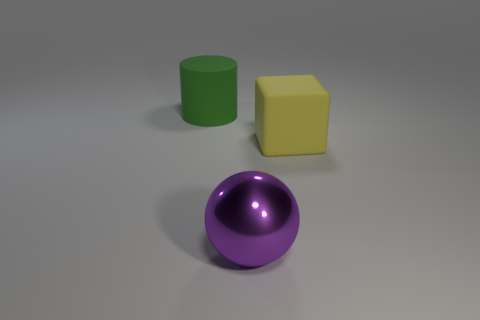Are there any other things that are made of the same material as the big ball?
Offer a terse response. No. How many big things are gray blocks or rubber things?
Your answer should be compact. 2. Is the large object behind the large yellow cube made of the same material as the large yellow cube?
Your answer should be very brief. Yes. There is a large object that is behind the big thing to the right of the big purple metal sphere; what is it made of?
Keep it short and to the point. Rubber. What size is the rubber thing that is in front of the thing that is to the left of the thing that is in front of the yellow matte thing?
Keep it short and to the point. Large. What number of cyan things are either large blocks or balls?
Your answer should be very brief. 0. There is a matte object that is to the right of the purple thing; is its shape the same as the purple object?
Make the answer very short. No. Are there more large rubber things that are behind the big rubber cube than gray objects?
Offer a terse response. Yes. How many yellow cubes have the same size as the purple metallic thing?
Your response must be concise. 1. How many objects are either tiny yellow metal blocks or large matte things on the right side of the big purple metal object?
Provide a succinct answer. 1. 